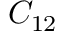<formula> <loc_0><loc_0><loc_500><loc_500>C _ { 1 2 }</formula> 